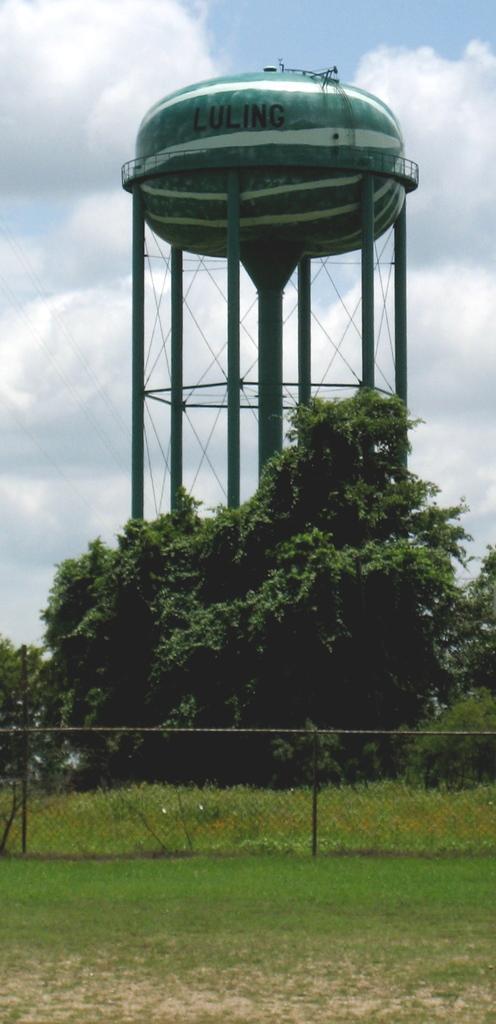Please provide a concise description of this image. In this image at front we can see fencing and there's grass on the surface. At the back side there are trees and water tank. At the background there is sky. 